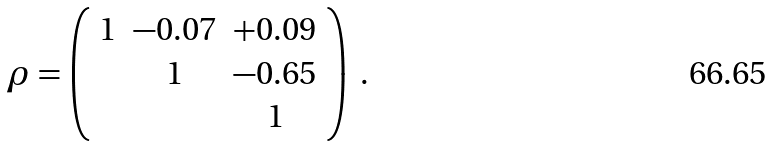<formula> <loc_0><loc_0><loc_500><loc_500>\rho = \left ( \begin{array} { c c c } 1 & - 0 . 0 7 & + 0 . 0 9 \\ & 1 & - 0 . 6 5 \\ & & 1 \end{array} \right ) \ .</formula> 